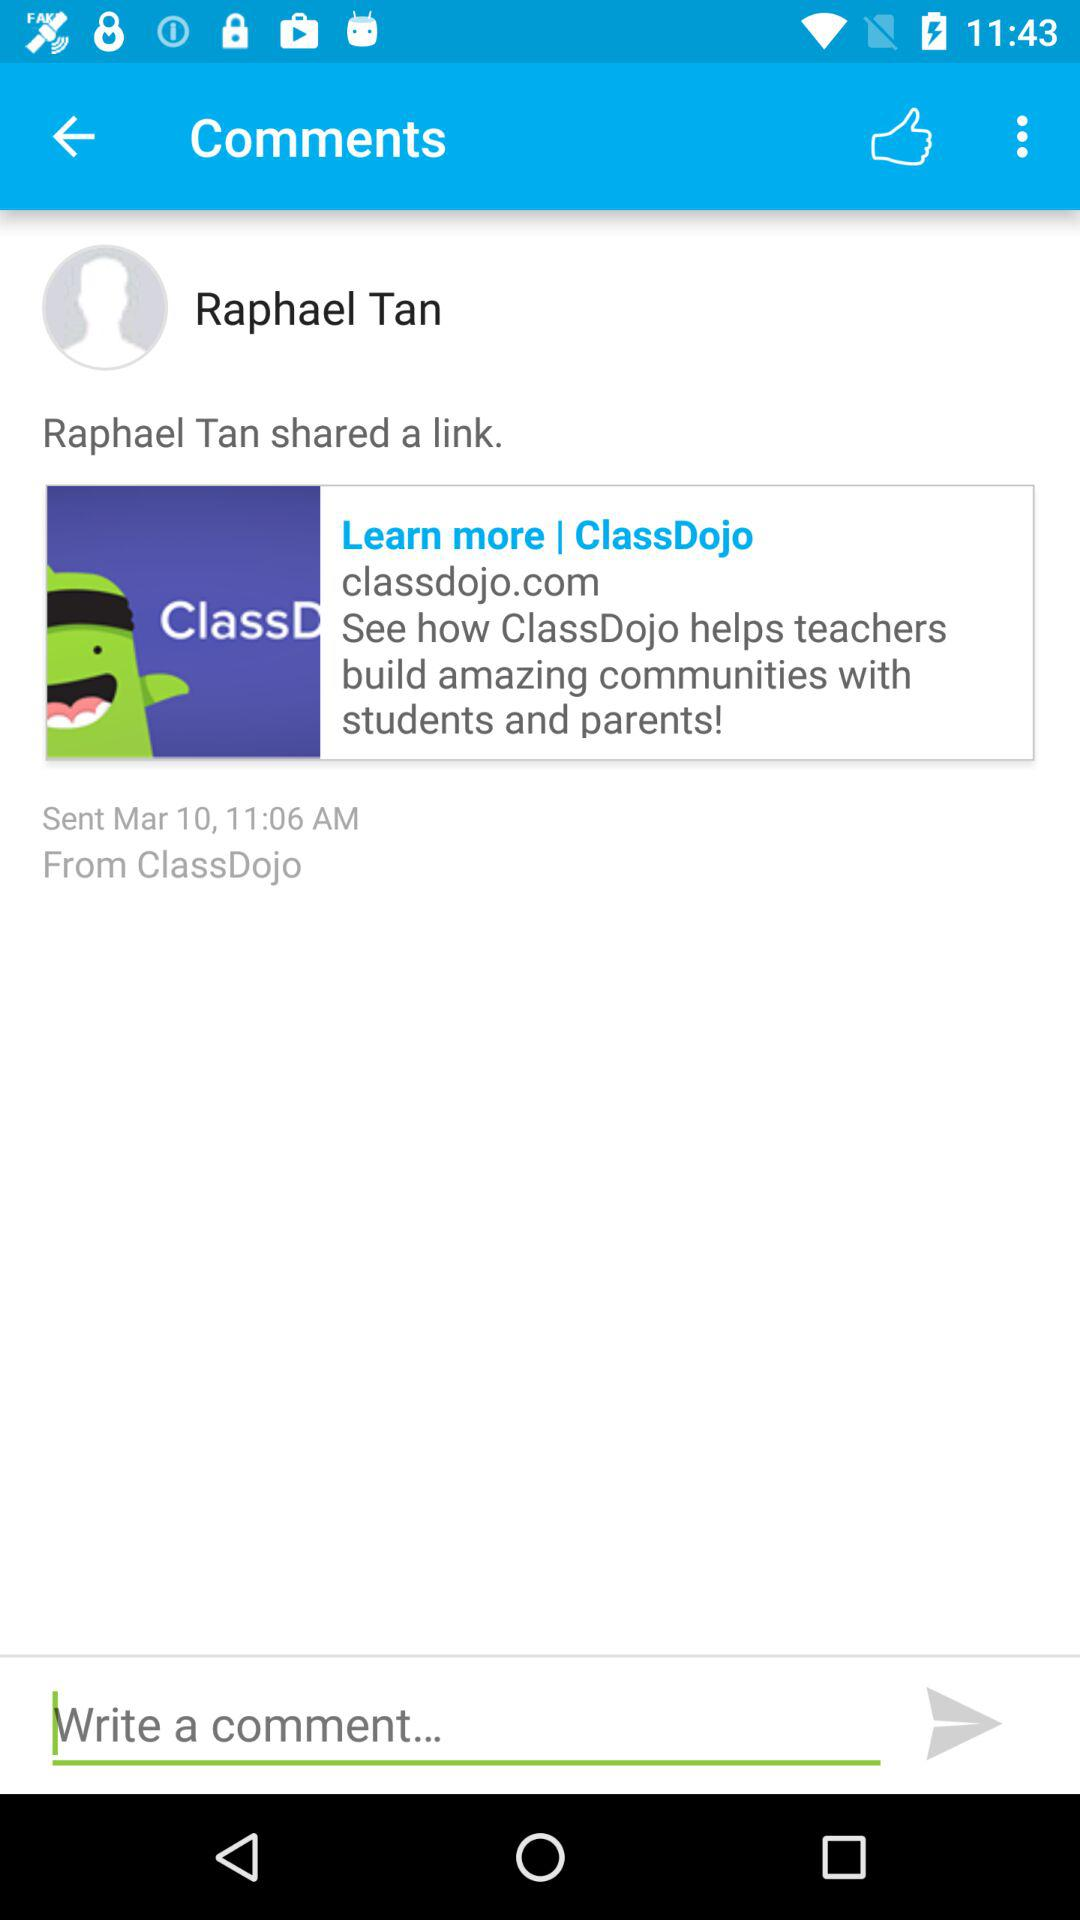What is the day on the selected date?
When the provided information is insufficient, respond with <no answer>. <no answer> 